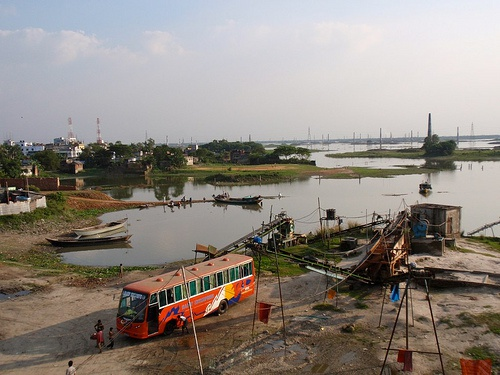Describe the objects in this image and their specific colors. I can see bus in darkgray, black, salmon, tan, and maroon tones, boat in darkgray, black, gray, and maroon tones, boat in darkgray and gray tones, boat in darkgray, black, and gray tones, and boat in darkgray, black, and gray tones in this image. 